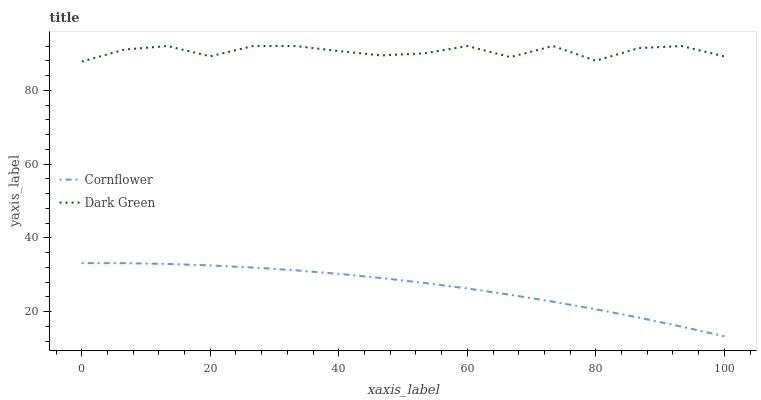Does Cornflower have the minimum area under the curve?
Answer yes or no. Yes. Does Dark Green have the maximum area under the curve?
Answer yes or no. Yes. Does Dark Green have the minimum area under the curve?
Answer yes or no. No. Is Cornflower the smoothest?
Answer yes or no. Yes. Is Dark Green the roughest?
Answer yes or no. Yes. Is Dark Green the smoothest?
Answer yes or no. No. Does Cornflower have the lowest value?
Answer yes or no. Yes. Does Dark Green have the lowest value?
Answer yes or no. No. Does Dark Green have the highest value?
Answer yes or no. Yes. Is Cornflower less than Dark Green?
Answer yes or no. Yes. Is Dark Green greater than Cornflower?
Answer yes or no. Yes. Does Cornflower intersect Dark Green?
Answer yes or no. No. 